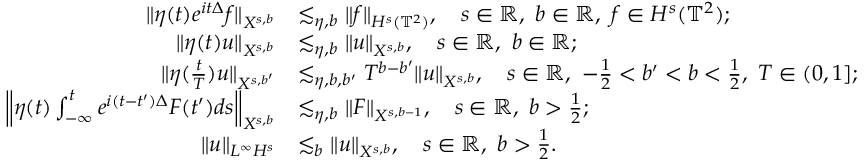Convert formula to latex. <formula><loc_0><loc_0><loc_500><loc_500>\begin{array} { r l } { \| \eta ( t ) e ^ { i t \Delta } f \| _ { X ^ { s , b } } } & { \lesssim _ { \eta , b } \| f \| _ { H ^ { s } ( \mathbb { T } ^ { 2 } ) } , \quad s \in \mathbb { R } , b \in \mathbb { R } , f \in H ^ { s } ( \mathbb { T } ^ { 2 } ) ; } \\ { \| \eta ( t ) u \| _ { X ^ { s , b } } } & { \lesssim _ { \eta , b } \| u \| _ { X ^ { s , b } } , \quad s \in \mathbb { R } , b \in \mathbb { R } ; } \\ { \| \eta ( \frac { t } { T } ) u \| _ { X ^ { s , b ^ { \prime } } } } & { \lesssim _ { \eta , b , b ^ { \prime } } T ^ { b - b ^ { \prime } } \| u \| _ { X ^ { s , b } } , \quad s \in \mathbb { R } , - \frac { 1 } { 2 } < b ^ { \prime } < b < \frac { 1 } { 2 } , T \in ( 0 , 1 ] ; } \\ { \left \| \eta ( t ) \int _ { - \infty } ^ { t } e ^ { i ( t - t ^ { \prime } ) \Delta } F ( t ^ { \prime } ) d s \right \| _ { X ^ { s , b } } } & { \lesssim _ { \eta , b } \| F \| _ { X ^ { s , b - 1 } } , \quad s \in \mathbb { R } , b > \frac { 1 } { 2 } ; } \\ { \| u \| _ { L ^ { \infty } H ^ { s } } } & { \lesssim _ { b } \| u \| _ { X ^ { s , b } } , \quad s \in \mathbb { R } , b > \frac { 1 } { 2 } . } \end{array}</formula> 